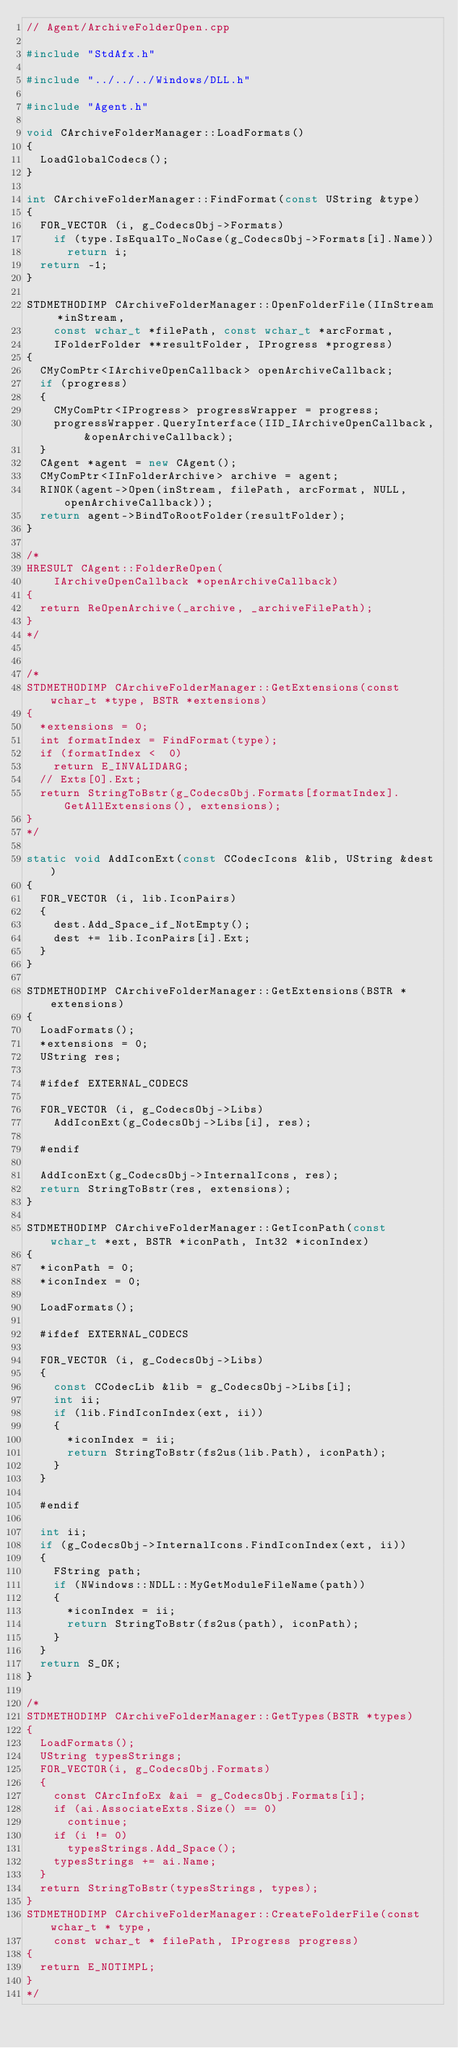<code> <loc_0><loc_0><loc_500><loc_500><_C++_>// Agent/ArchiveFolderOpen.cpp

#include "StdAfx.h"

#include "../../../Windows/DLL.h"

#include "Agent.h"

void CArchiveFolderManager::LoadFormats()
{
  LoadGlobalCodecs();
}

int CArchiveFolderManager::FindFormat(const UString &type)
{
  FOR_VECTOR (i, g_CodecsObj->Formats)
    if (type.IsEqualTo_NoCase(g_CodecsObj->Formats[i].Name))
      return i;
  return -1;
}

STDMETHODIMP CArchiveFolderManager::OpenFolderFile(IInStream *inStream,
    const wchar_t *filePath, const wchar_t *arcFormat,
    IFolderFolder **resultFolder, IProgress *progress)
{
  CMyComPtr<IArchiveOpenCallback> openArchiveCallback;
  if (progress)
  {
    CMyComPtr<IProgress> progressWrapper = progress;
    progressWrapper.QueryInterface(IID_IArchiveOpenCallback, &openArchiveCallback);
  }
  CAgent *agent = new CAgent();
  CMyComPtr<IInFolderArchive> archive = agent;
  RINOK(agent->Open(inStream, filePath, arcFormat, NULL, openArchiveCallback));
  return agent->BindToRootFolder(resultFolder);
}

/*
HRESULT CAgent::FolderReOpen(
    IArchiveOpenCallback *openArchiveCallback)
{
  return ReOpenArchive(_archive, _archiveFilePath);
}
*/


/*
STDMETHODIMP CArchiveFolderManager::GetExtensions(const wchar_t *type, BSTR *extensions)
{
  *extensions = 0;
  int formatIndex = FindFormat(type);
  if (formatIndex <  0)
    return E_INVALIDARG;
  // Exts[0].Ext;
  return StringToBstr(g_CodecsObj.Formats[formatIndex].GetAllExtensions(), extensions);
}
*/

static void AddIconExt(const CCodecIcons &lib, UString &dest)
{
  FOR_VECTOR (i, lib.IconPairs)
  {
    dest.Add_Space_if_NotEmpty();
    dest += lib.IconPairs[i].Ext;
  }
}

STDMETHODIMP CArchiveFolderManager::GetExtensions(BSTR *extensions)
{
  LoadFormats();
  *extensions = 0;
  UString res;
  
  #ifdef EXTERNAL_CODECS
  
  FOR_VECTOR (i, g_CodecsObj->Libs)
    AddIconExt(g_CodecsObj->Libs[i], res);
  
  #endif
  
  AddIconExt(g_CodecsObj->InternalIcons, res);
  return StringToBstr(res, extensions);
}

STDMETHODIMP CArchiveFolderManager::GetIconPath(const wchar_t *ext, BSTR *iconPath, Int32 *iconIndex)
{
  *iconPath = 0;
  *iconIndex = 0;

  LoadFormats();

  #ifdef EXTERNAL_CODECS

  FOR_VECTOR (i, g_CodecsObj->Libs)
  {
    const CCodecLib &lib = g_CodecsObj->Libs[i];
    int ii;
    if (lib.FindIconIndex(ext, ii))
    {
      *iconIndex = ii;
      return StringToBstr(fs2us(lib.Path), iconPath);
    }
  }
  
  #endif

  int ii;
  if (g_CodecsObj->InternalIcons.FindIconIndex(ext, ii))
  {
    FString path;
    if (NWindows::NDLL::MyGetModuleFileName(path))
    {
      *iconIndex = ii;
      return StringToBstr(fs2us(path), iconPath);
    }
  }
  return S_OK;
}

/*
STDMETHODIMP CArchiveFolderManager::GetTypes(BSTR *types)
{
  LoadFormats();
  UString typesStrings;
  FOR_VECTOR(i, g_CodecsObj.Formats)
  {
    const CArcInfoEx &ai = g_CodecsObj.Formats[i];
    if (ai.AssociateExts.Size() == 0)
      continue;
    if (i != 0)
      typesStrings.Add_Space();
    typesStrings += ai.Name;
  }
  return StringToBstr(typesStrings, types);
}
STDMETHODIMP CArchiveFolderManager::CreateFolderFile(const wchar_t * type,
    const wchar_t * filePath, IProgress progress)
{
  return E_NOTIMPL;
}
*/
</code> 